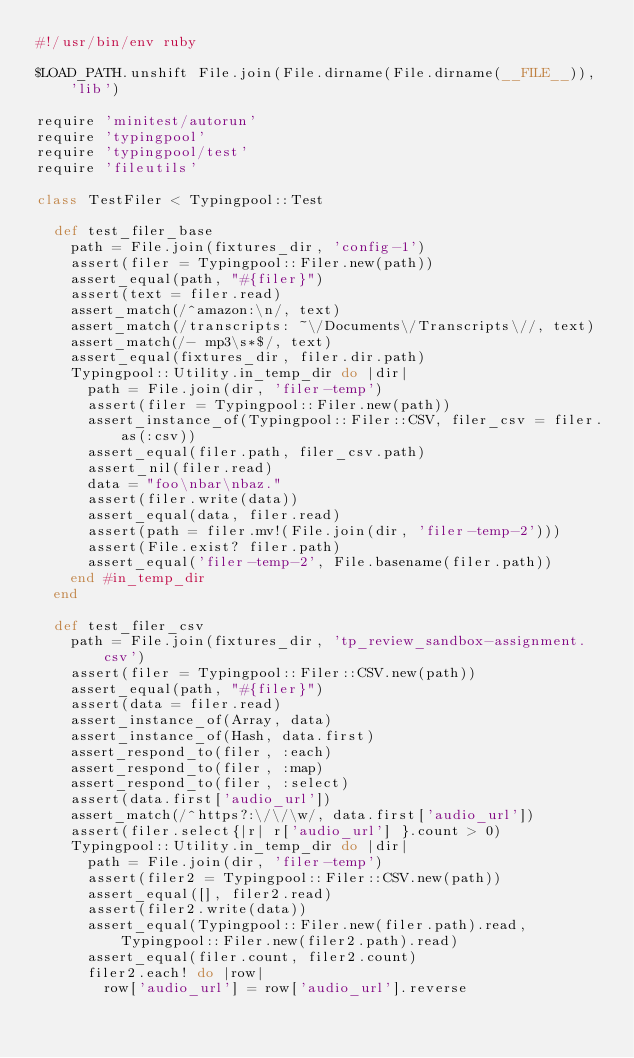<code> <loc_0><loc_0><loc_500><loc_500><_Ruby_>#!/usr/bin/env ruby

$LOAD_PATH.unshift File.join(File.dirname(File.dirname(__FILE__)), 'lib')

require 'minitest/autorun'
require 'typingpool'
require 'typingpool/test'
require 'fileutils'

class TestFiler < Typingpool::Test

  def test_filer_base
    path = File.join(fixtures_dir, 'config-1')
    assert(filer = Typingpool::Filer.new(path))
    assert_equal(path, "#{filer}")
    assert(text = filer.read)
    assert_match(/^amazon:\n/, text)
    assert_match(/transcripts: ~\/Documents\/Transcripts\//, text)
    assert_match(/- mp3\s*$/, text)
    assert_equal(fixtures_dir, filer.dir.path)
    Typingpool::Utility.in_temp_dir do |dir|
      path = File.join(dir, 'filer-temp')
      assert(filer = Typingpool::Filer.new(path))
      assert_instance_of(Typingpool::Filer::CSV, filer_csv = filer.as(:csv))
      assert_equal(filer.path, filer_csv.path)
      assert_nil(filer.read)
      data = "foo\nbar\nbaz."
      assert(filer.write(data))
      assert_equal(data, filer.read)
      assert(path = filer.mv!(File.join(dir, 'filer-temp-2')))
      assert(File.exist? filer.path)
      assert_equal('filer-temp-2', File.basename(filer.path))
    end #in_temp_dir
  end

  def test_filer_csv
    path = File.join(fixtures_dir, 'tp_review_sandbox-assignment.csv')
    assert(filer = Typingpool::Filer::CSV.new(path))
    assert_equal(path, "#{filer}")
    assert(data = filer.read)
    assert_instance_of(Array, data)
    assert_instance_of(Hash, data.first)
    assert_respond_to(filer, :each)
    assert_respond_to(filer, :map)
    assert_respond_to(filer, :select)
    assert(data.first['audio_url'])
    assert_match(/^https?:\/\/\w/, data.first['audio_url'])
    assert(filer.select{|r| r['audio_url'] }.count > 0)
    Typingpool::Utility.in_temp_dir do |dir|
      path = File.join(dir, 'filer-temp')
      assert(filer2 = Typingpool::Filer::CSV.new(path))
      assert_equal([], filer2.read)
      assert(filer2.write(data))
      assert_equal(Typingpool::Filer.new(filer.path).read, Typingpool::Filer.new(filer2.path).read)
      assert_equal(filer.count, filer2.count)
      filer2.each! do |row|
        row['audio_url'] = row['audio_url'].reverse</code> 